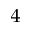<formula> <loc_0><loc_0><loc_500><loc_500>^ { 4 }</formula> 